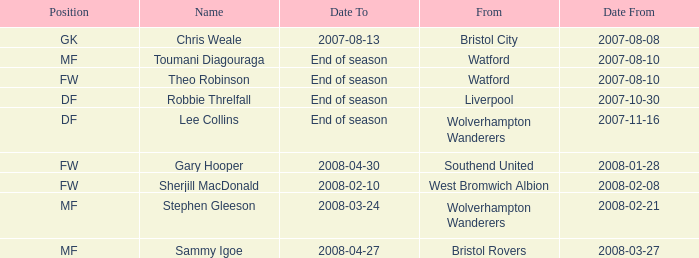What date did Toumani Diagouraga, who played position MF, start? 2007-08-10. 